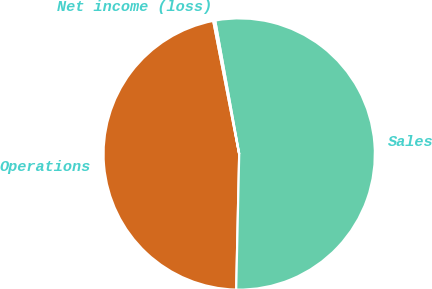<chart> <loc_0><loc_0><loc_500><loc_500><pie_chart><fcel>Operations<fcel>Sales<fcel>Net income (loss)<nl><fcel>46.58%<fcel>53.19%<fcel>0.23%<nl></chart> 